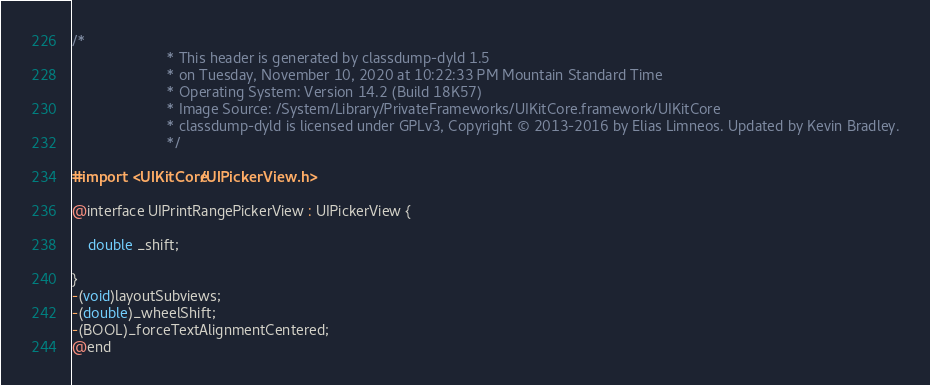Convert code to text. <code><loc_0><loc_0><loc_500><loc_500><_C_>/*
                       * This header is generated by classdump-dyld 1.5
                       * on Tuesday, November 10, 2020 at 10:22:33 PM Mountain Standard Time
                       * Operating System: Version 14.2 (Build 18K57)
                       * Image Source: /System/Library/PrivateFrameworks/UIKitCore.framework/UIKitCore
                       * classdump-dyld is licensed under GPLv3, Copyright © 2013-2016 by Elias Limneos. Updated by Kevin Bradley.
                       */

#import <UIKitCore/UIPickerView.h>

@interface UIPrintRangePickerView : UIPickerView {

	double _shift;

}
-(void)layoutSubviews;
-(double)_wheelShift;
-(BOOL)_forceTextAlignmentCentered;
@end

</code> 